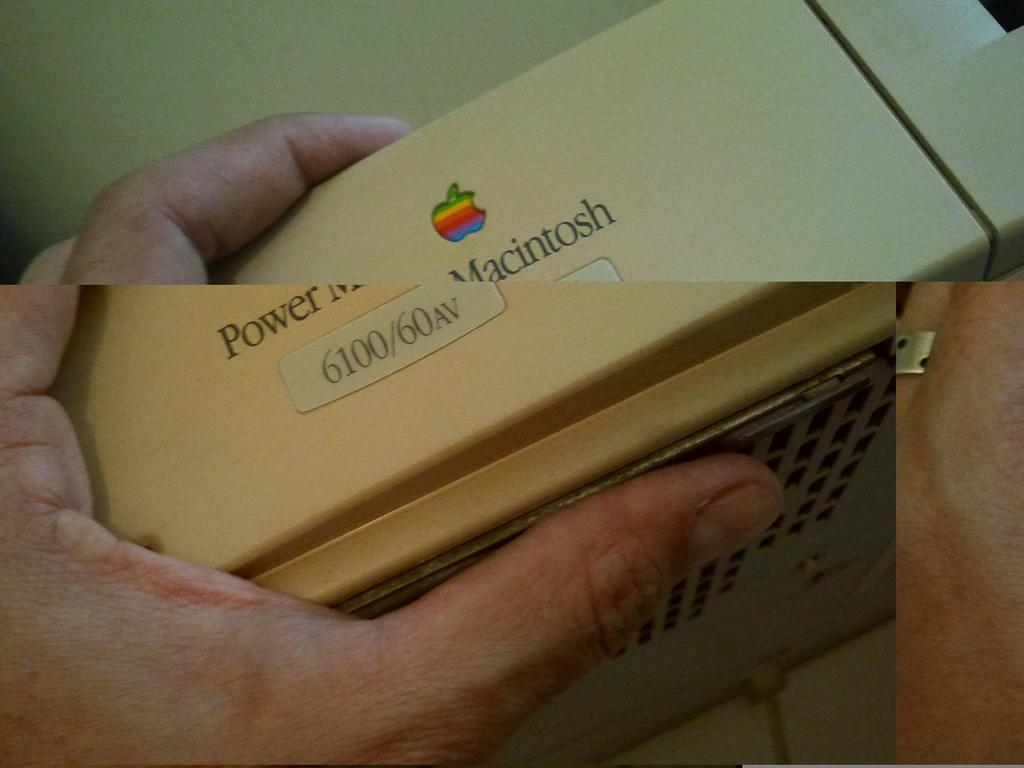<image>
Describe the image concisely. The model number 6100 is on a white Apple box. 